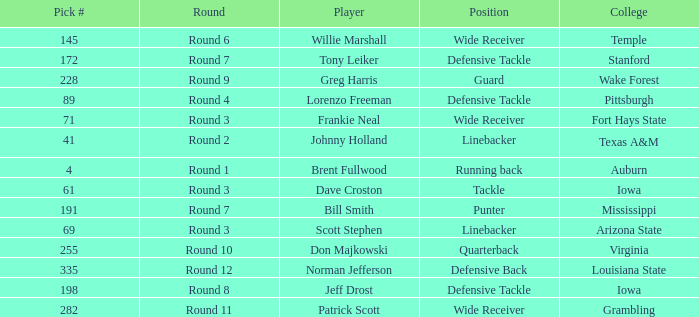What is the sum of pick# for Don Majkowski?3 255.0. 